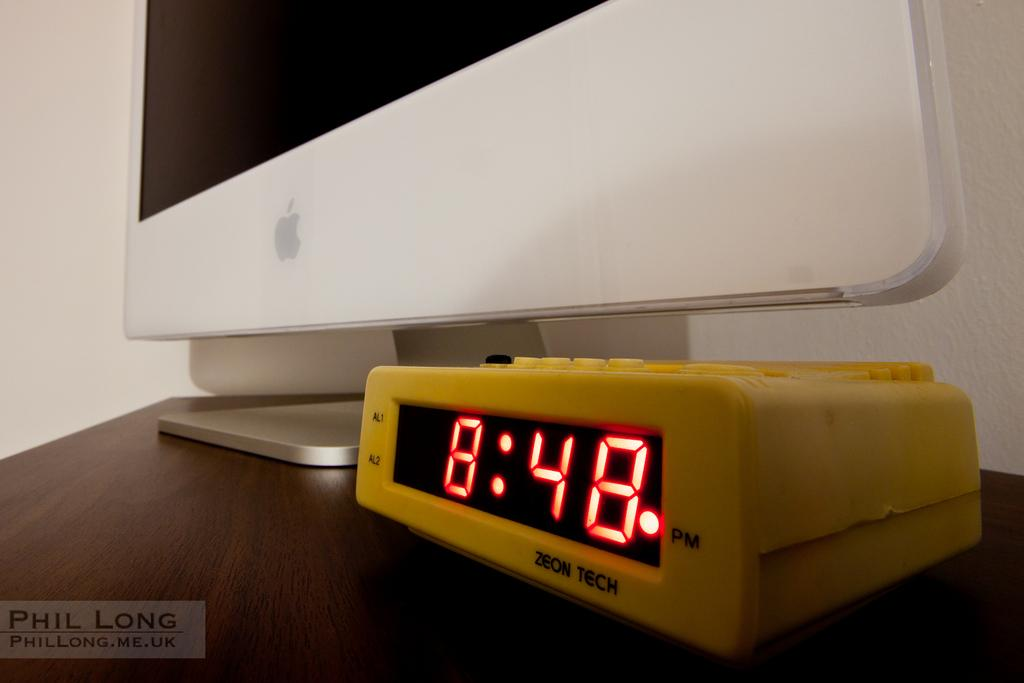Provide a one-sentence caption for the provided image. The clock next to the monitor states that it is 8:48 pm. 